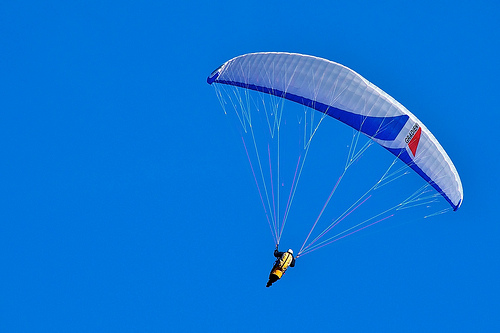Imagine you are interviewing the person in this image. What might one of your questions be, and provide their potential detailed response. Q: 'What inspired you to take up paragliding, and how has the experience been so far?'

A: 'I've always been fascinated by the idea of flying and experiencing the world from a different perspective. Paragliding offered the perfect blend of adventure and serenity. The first time I took to the skies, I felt an unmatched sense of freedom and excitement. It's been an amazing journey learning to control the parachute, handle different weather conditions, and explore stunning landscapes from above. Each flight is unique and brings its own set of challenges and rewards, making it a truly enriching experience.' 